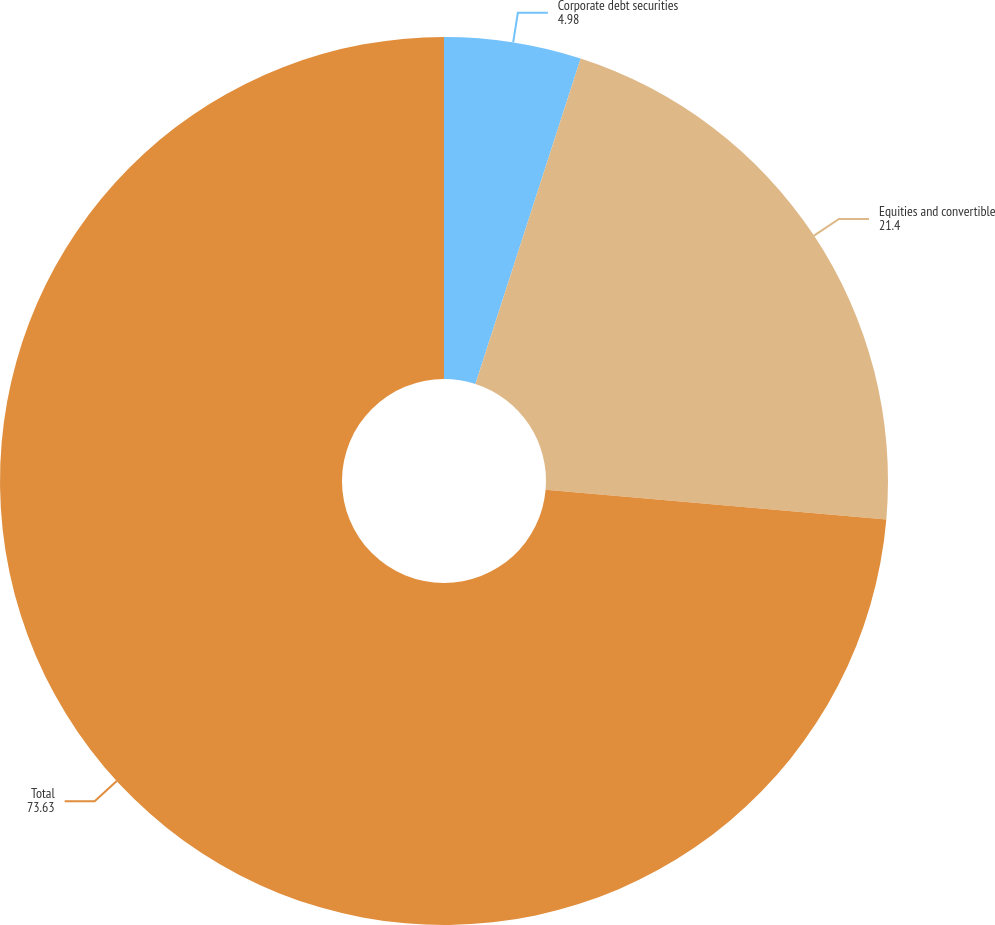<chart> <loc_0><loc_0><loc_500><loc_500><pie_chart><fcel>Corporate debt securities<fcel>Equities and convertible<fcel>Total<nl><fcel>4.98%<fcel>21.4%<fcel>73.63%<nl></chart> 